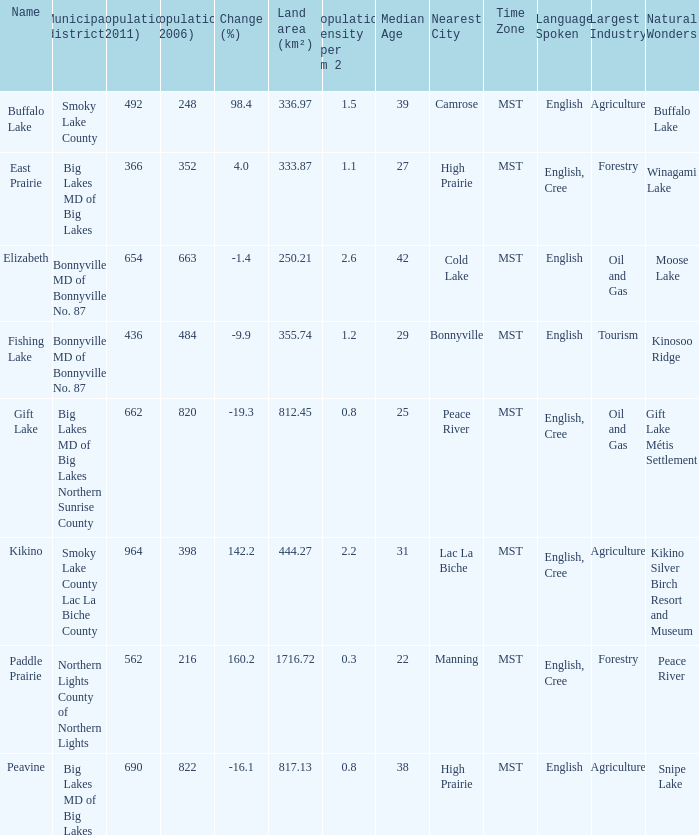What place is there a change of -19.3? 1.0. 